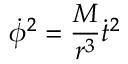Convert formula to latex. <formula><loc_0><loc_0><loc_500><loc_500>{ \dot { \phi } } ^ { 2 } = { \frac { M } { r ^ { 3 } } } { \dot { t } } ^ { 2 }</formula> 